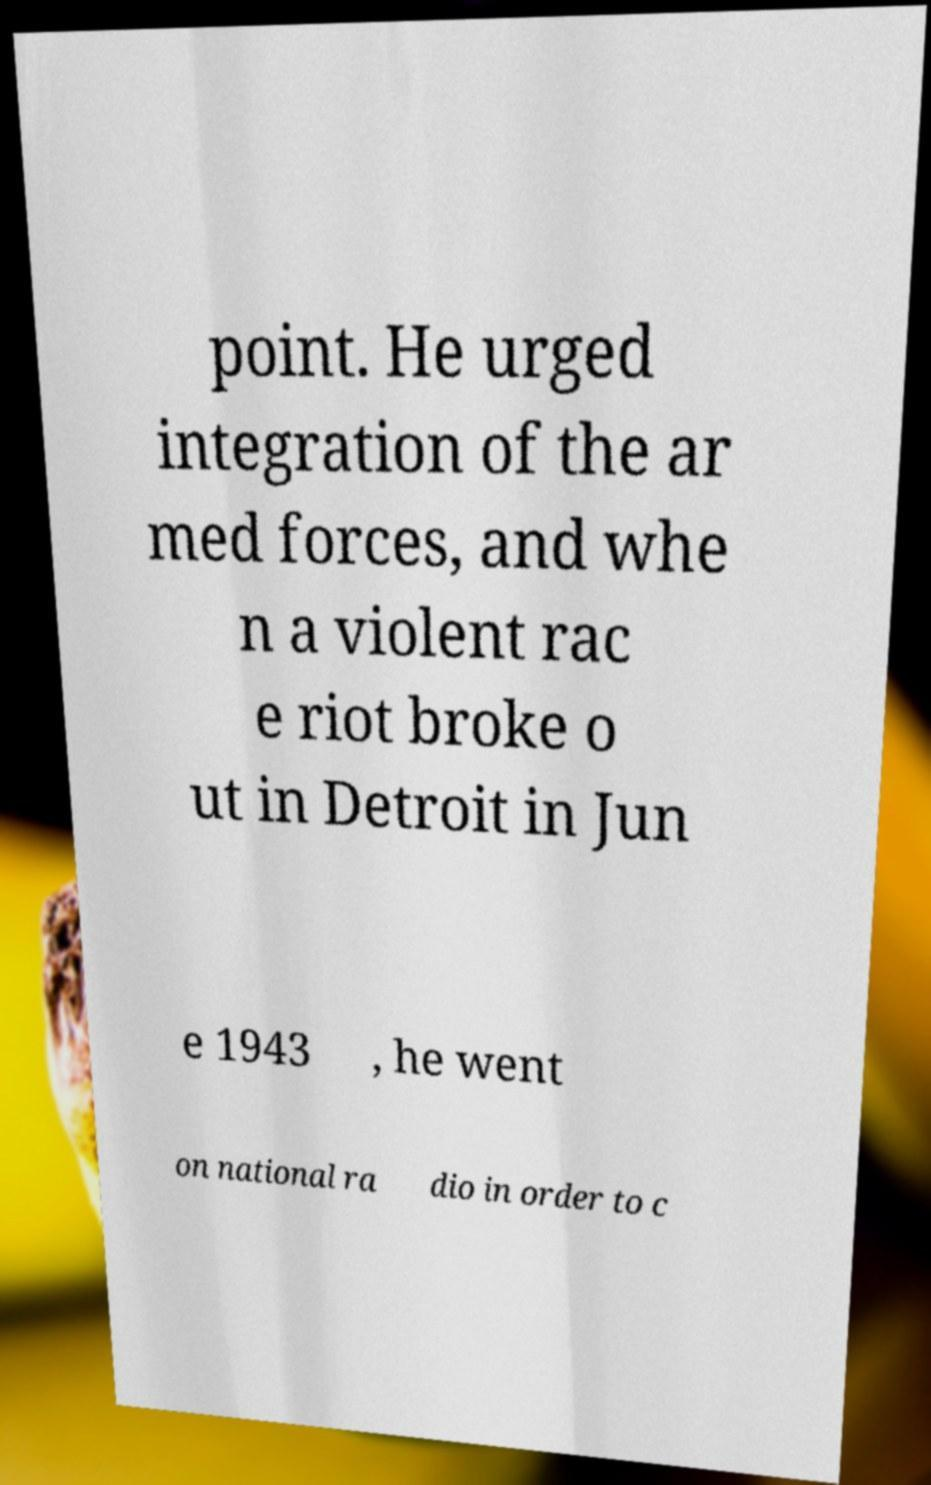Could you extract and type out the text from this image? point. He urged integration of the ar med forces, and whe n a violent rac e riot broke o ut in Detroit in Jun e 1943 , he went on national ra dio in order to c 